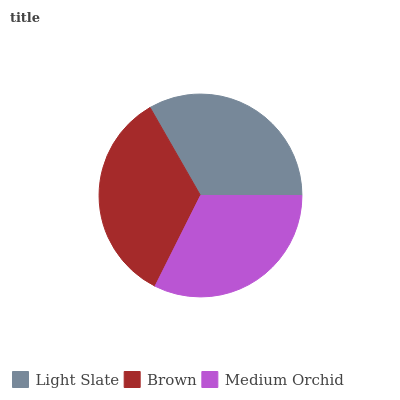Is Medium Orchid the minimum?
Answer yes or no. Yes. Is Brown the maximum?
Answer yes or no. Yes. Is Brown the minimum?
Answer yes or no. No. Is Medium Orchid the maximum?
Answer yes or no. No. Is Brown greater than Medium Orchid?
Answer yes or no. Yes. Is Medium Orchid less than Brown?
Answer yes or no. Yes. Is Medium Orchid greater than Brown?
Answer yes or no. No. Is Brown less than Medium Orchid?
Answer yes or no. No. Is Light Slate the high median?
Answer yes or no. Yes. Is Light Slate the low median?
Answer yes or no. Yes. Is Medium Orchid the high median?
Answer yes or no. No. Is Brown the low median?
Answer yes or no. No. 